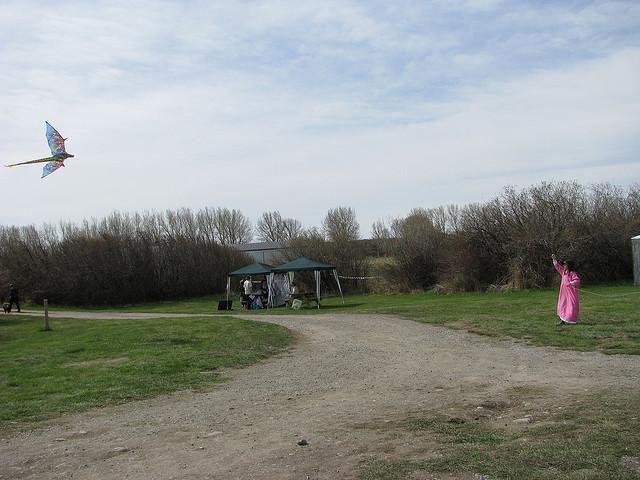What color is the building?
Short answer required. Green. Do the trees have leaves?
Answer briefly. No. What is the bench made of?
Concise answer only. Wood. How many tents are in the background?
Be succinct. 2. Is this a paved walkway?
Write a very short answer. No. What is the girl holding?
Keep it brief. Kite. Is this a gravel or a dirt road?
Short answer required. Dirt. What color is the person's coat?
Give a very brief answer. Pink. How many kites are in the air?
Be succinct. 1. Is this a park?
Write a very short answer. Yes. What color is the woman's dress?
Quick response, please. Pink. Are the lawns well manicured?
Write a very short answer. No. Is there any people in this photo?
Concise answer only. Yes. What is the girl playing with?
Give a very brief answer. Kite. 